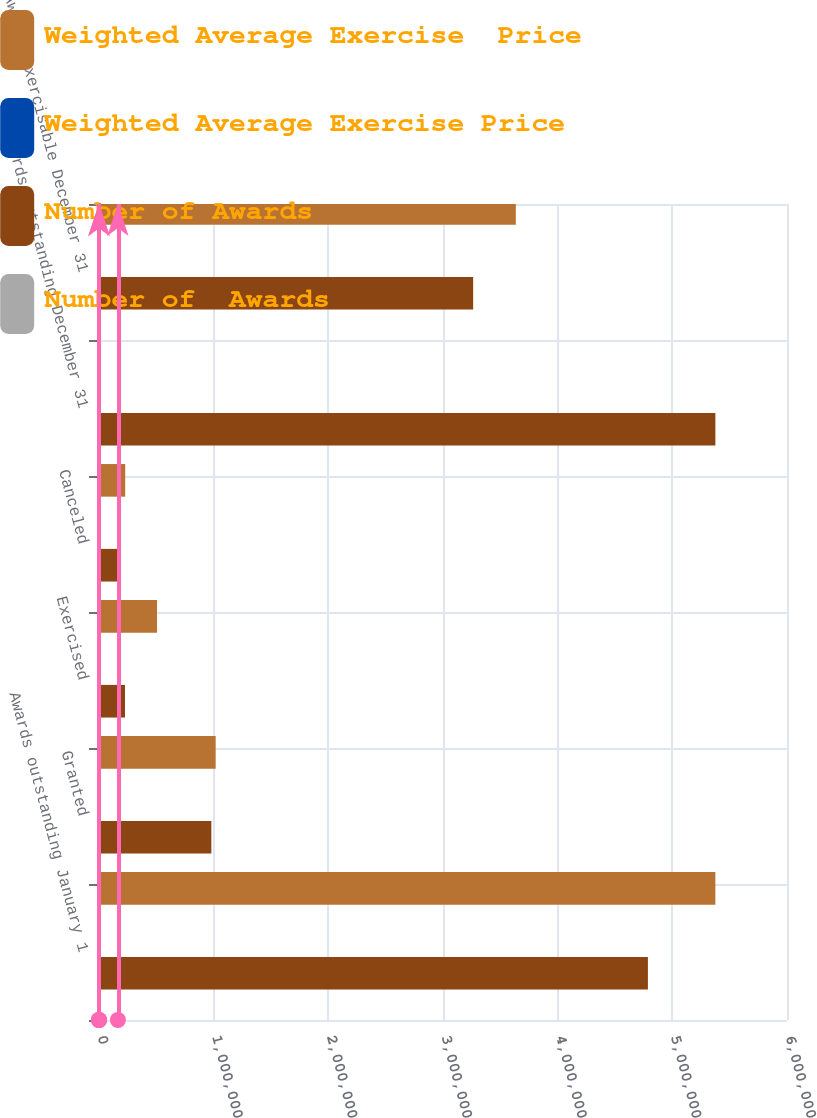<chart> <loc_0><loc_0><loc_500><loc_500><stacked_bar_chart><ecel><fcel>Awards outstanding January 1<fcel>Granted<fcel>Exercised<fcel>Canceled<fcel>Awards outstanding December 31<fcel>Awards exercisable December 31<nl><fcel>Weighted Average Exercise  Price<fcel>5.3754e+06<fcel>1.0175e+06<fcel>506154<fcel>228750<fcel>43.63<fcel>3.63507e+06<nl><fcel>Weighted Average Exercise Price<fcel>30.84<fcel>27.9<fcel>16.55<fcel>39.34<fcel>31.24<fcel>28.44<nl><fcel>Number of Awards<fcel>4.78704e+06<fcel>980000<fcel>226695<fcel>164946<fcel>5.3754e+06<fcel>3.26298e+06<nl><fcel>Number of  Awards<fcel>28.09<fcel>43.63<fcel>19.96<fcel>41.96<fcel>30.84<fcel>24.1<nl></chart> 